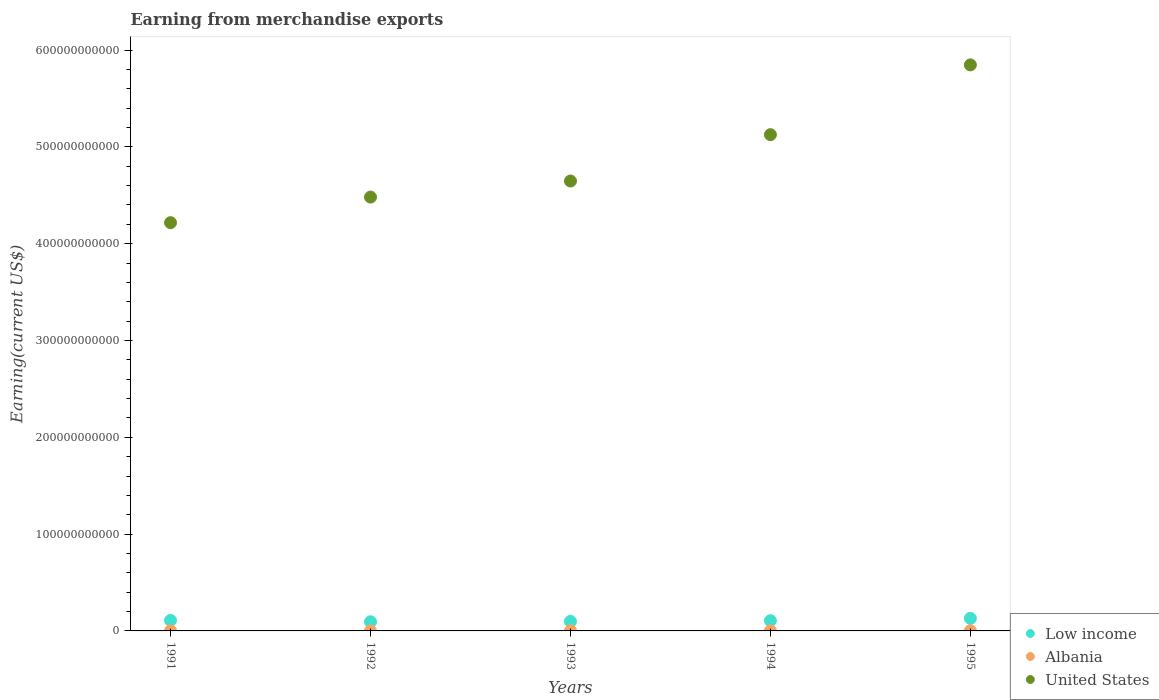How many different coloured dotlines are there?
Offer a terse response. 3. What is the amount earned from merchandise exports in United States in 1993?
Your answer should be compact. 4.65e+11. Across all years, what is the maximum amount earned from merchandise exports in Low income?
Your answer should be very brief. 1.30e+1. Across all years, what is the minimum amount earned from merchandise exports in United States?
Your answer should be very brief. 4.22e+11. What is the total amount earned from merchandise exports in Albania in the graph?
Provide a succinct answer. 6.37e+08. What is the difference between the amount earned from merchandise exports in United States in 1991 and that in 1995?
Give a very brief answer. -1.63e+11. What is the difference between the amount earned from merchandise exports in Low income in 1994 and the amount earned from merchandise exports in Albania in 1992?
Provide a succinct answer. 1.05e+1. What is the average amount earned from merchandise exports in United States per year?
Provide a short and direct response. 4.86e+11. In the year 1993, what is the difference between the amount earned from merchandise exports in United States and amount earned from merchandise exports in Albania?
Provide a short and direct response. 4.65e+11. What is the ratio of the amount earned from merchandise exports in Low income in 1993 to that in 1994?
Your answer should be very brief. 0.94. What is the difference between the highest and the second highest amount earned from merchandise exports in Albania?
Offer a terse response. 5.93e+07. What is the difference between the highest and the lowest amount earned from merchandise exports in Albania?
Keep it short and to the point. 1.32e+08. In how many years, is the amount earned from merchandise exports in Albania greater than the average amount earned from merchandise exports in Albania taken over all years?
Give a very brief answer. 2. Does the amount earned from merchandise exports in Low income monotonically increase over the years?
Provide a succinct answer. No. Is the amount earned from merchandise exports in United States strictly greater than the amount earned from merchandise exports in Low income over the years?
Give a very brief answer. Yes. How many dotlines are there?
Provide a short and direct response. 3. What is the difference between two consecutive major ticks on the Y-axis?
Make the answer very short. 1.00e+11. Are the values on the major ticks of Y-axis written in scientific E-notation?
Make the answer very short. No. Where does the legend appear in the graph?
Provide a succinct answer. Bottom right. How many legend labels are there?
Make the answer very short. 3. How are the legend labels stacked?
Give a very brief answer. Vertical. What is the title of the graph?
Provide a short and direct response. Earning from merchandise exports. Does "Bahrain" appear as one of the legend labels in the graph?
Your answer should be very brief. No. What is the label or title of the Y-axis?
Your answer should be very brief. Earning(current US$). What is the Earning(current US$) in Low income in 1991?
Ensure brevity in your answer.  1.08e+1. What is the Earning(current US$) in Albania in 1991?
Make the answer very short. 1.00e+08. What is the Earning(current US$) of United States in 1991?
Offer a terse response. 4.22e+11. What is the Earning(current US$) in Low income in 1992?
Offer a terse response. 9.42e+09. What is the Earning(current US$) in Albania in 1992?
Make the answer very short. 7.00e+07. What is the Earning(current US$) of United States in 1992?
Provide a succinct answer. 4.48e+11. What is the Earning(current US$) in Low income in 1993?
Keep it short and to the point. 9.91e+09. What is the Earning(current US$) of Albania in 1993?
Your answer should be very brief. 1.22e+08. What is the Earning(current US$) of United States in 1993?
Make the answer very short. 4.65e+11. What is the Earning(current US$) in Low income in 1994?
Offer a terse response. 1.06e+1. What is the Earning(current US$) of Albania in 1994?
Your answer should be very brief. 1.43e+08. What is the Earning(current US$) in United States in 1994?
Offer a very short reply. 5.13e+11. What is the Earning(current US$) of Low income in 1995?
Offer a very short reply. 1.30e+1. What is the Earning(current US$) in Albania in 1995?
Your answer should be compact. 2.02e+08. What is the Earning(current US$) of United States in 1995?
Ensure brevity in your answer.  5.85e+11. Across all years, what is the maximum Earning(current US$) in Low income?
Provide a short and direct response. 1.30e+1. Across all years, what is the maximum Earning(current US$) of Albania?
Your answer should be compact. 2.02e+08. Across all years, what is the maximum Earning(current US$) of United States?
Your response must be concise. 5.85e+11. Across all years, what is the minimum Earning(current US$) of Low income?
Your answer should be compact. 9.42e+09. Across all years, what is the minimum Earning(current US$) in Albania?
Provide a short and direct response. 7.00e+07. Across all years, what is the minimum Earning(current US$) of United States?
Your response must be concise. 4.22e+11. What is the total Earning(current US$) of Low income in the graph?
Ensure brevity in your answer.  5.38e+1. What is the total Earning(current US$) of Albania in the graph?
Give a very brief answer. 6.37e+08. What is the total Earning(current US$) of United States in the graph?
Offer a very short reply. 2.43e+12. What is the difference between the Earning(current US$) in Low income in 1991 and that in 1992?
Provide a short and direct response. 1.42e+09. What is the difference between the Earning(current US$) in Albania in 1991 and that in 1992?
Your answer should be compact. 3.00e+07. What is the difference between the Earning(current US$) of United States in 1991 and that in 1992?
Provide a succinct answer. -2.64e+1. What is the difference between the Earning(current US$) in Low income in 1991 and that in 1993?
Your answer should be compact. 9.40e+08. What is the difference between the Earning(current US$) of Albania in 1991 and that in 1993?
Provide a short and direct response. -2.25e+07. What is the difference between the Earning(current US$) in United States in 1991 and that in 1993?
Your response must be concise. -4.30e+1. What is the difference between the Earning(current US$) in Low income in 1991 and that in 1994?
Your answer should be very brief. 2.65e+08. What is the difference between the Earning(current US$) of Albania in 1991 and that in 1994?
Offer a very short reply. -4.27e+07. What is the difference between the Earning(current US$) in United States in 1991 and that in 1994?
Your answer should be compact. -9.09e+1. What is the difference between the Earning(current US$) in Low income in 1991 and that in 1995?
Keep it short and to the point. -2.14e+09. What is the difference between the Earning(current US$) in Albania in 1991 and that in 1995?
Your answer should be very brief. -1.02e+08. What is the difference between the Earning(current US$) in United States in 1991 and that in 1995?
Provide a short and direct response. -1.63e+11. What is the difference between the Earning(current US$) of Low income in 1992 and that in 1993?
Offer a terse response. -4.84e+08. What is the difference between the Earning(current US$) of Albania in 1992 and that in 1993?
Offer a very short reply. -5.25e+07. What is the difference between the Earning(current US$) of United States in 1992 and that in 1993?
Offer a very short reply. -1.66e+1. What is the difference between the Earning(current US$) in Low income in 1992 and that in 1994?
Your answer should be compact. -1.16e+09. What is the difference between the Earning(current US$) in Albania in 1992 and that in 1994?
Your answer should be very brief. -7.27e+07. What is the difference between the Earning(current US$) in United States in 1992 and that in 1994?
Keep it short and to the point. -6.45e+1. What is the difference between the Earning(current US$) of Low income in 1992 and that in 1995?
Provide a short and direct response. -3.57e+09. What is the difference between the Earning(current US$) in Albania in 1992 and that in 1995?
Your response must be concise. -1.32e+08. What is the difference between the Earning(current US$) of United States in 1992 and that in 1995?
Give a very brief answer. -1.37e+11. What is the difference between the Earning(current US$) of Low income in 1993 and that in 1994?
Keep it short and to the point. -6.75e+08. What is the difference between the Earning(current US$) of Albania in 1993 and that in 1994?
Your answer should be compact. -2.02e+07. What is the difference between the Earning(current US$) in United States in 1993 and that in 1994?
Offer a terse response. -4.79e+1. What is the difference between the Earning(current US$) in Low income in 1993 and that in 1995?
Give a very brief answer. -3.08e+09. What is the difference between the Earning(current US$) in Albania in 1993 and that in 1995?
Offer a very short reply. -7.95e+07. What is the difference between the Earning(current US$) of United States in 1993 and that in 1995?
Provide a succinct answer. -1.20e+11. What is the difference between the Earning(current US$) of Low income in 1994 and that in 1995?
Your answer should be very brief. -2.41e+09. What is the difference between the Earning(current US$) in Albania in 1994 and that in 1995?
Offer a very short reply. -5.93e+07. What is the difference between the Earning(current US$) of United States in 1994 and that in 1995?
Make the answer very short. -7.21e+1. What is the difference between the Earning(current US$) of Low income in 1991 and the Earning(current US$) of Albania in 1992?
Keep it short and to the point. 1.08e+1. What is the difference between the Earning(current US$) in Low income in 1991 and the Earning(current US$) in United States in 1992?
Your answer should be compact. -4.37e+11. What is the difference between the Earning(current US$) of Albania in 1991 and the Earning(current US$) of United States in 1992?
Ensure brevity in your answer.  -4.48e+11. What is the difference between the Earning(current US$) in Low income in 1991 and the Earning(current US$) in Albania in 1993?
Keep it short and to the point. 1.07e+1. What is the difference between the Earning(current US$) of Low income in 1991 and the Earning(current US$) of United States in 1993?
Your answer should be very brief. -4.54e+11. What is the difference between the Earning(current US$) in Albania in 1991 and the Earning(current US$) in United States in 1993?
Provide a short and direct response. -4.65e+11. What is the difference between the Earning(current US$) of Low income in 1991 and the Earning(current US$) of Albania in 1994?
Your answer should be very brief. 1.07e+1. What is the difference between the Earning(current US$) of Low income in 1991 and the Earning(current US$) of United States in 1994?
Your answer should be very brief. -5.02e+11. What is the difference between the Earning(current US$) of Albania in 1991 and the Earning(current US$) of United States in 1994?
Your answer should be compact. -5.13e+11. What is the difference between the Earning(current US$) of Low income in 1991 and the Earning(current US$) of Albania in 1995?
Your response must be concise. 1.06e+1. What is the difference between the Earning(current US$) of Low income in 1991 and the Earning(current US$) of United States in 1995?
Make the answer very short. -5.74e+11. What is the difference between the Earning(current US$) in Albania in 1991 and the Earning(current US$) in United States in 1995?
Keep it short and to the point. -5.85e+11. What is the difference between the Earning(current US$) in Low income in 1992 and the Earning(current US$) in Albania in 1993?
Your answer should be compact. 9.30e+09. What is the difference between the Earning(current US$) of Low income in 1992 and the Earning(current US$) of United States in 1993?
Provide a short and direct response. -4.55e+11. What is the difference between the Earning(current US$) of Albania in 1992 and the Earning(current US$) of United States in 1993?
Your answer should be compact. -4.65e+11. What is the difference between the Earning(current US$) in Low income in 1992 and the Earning(current US$) in Albania in 1994?
Your answer should be compact. 9.28e+09. What is the difference between the Earning(current US$) of Low income in 1992 and the Earning(current US$) of United States in 1994?
Give a very brief answer. -5.03e+11. What is the difference between the Earning(current US$) of Albania in 1992 and the Earning(current US$) of United States in 1994?
Provide a succinct answer. -5.13e+11. What is the difference between the Earning(current US$) of Low income in 1992 and the Earning(current US$) of Albania in 1995?
Provide a succinct answer. 9.22e+09. What is the difference between the Earning(current US$) in Low income in 1992 and the Earning(current US$) in United States in 1995?
Ensure brevity in your answer.  -5.75e+11. What is the difference between the Earning(current US$) of Albania in 1992 and the Earning(current US$) of United States in 1995?
Your answer should be compact. -5.85e+11. What is the difference between the Earning(current US$) of Low income in 1993 and the Earning(current US$) of Albania in 1994?
Keep it short and to the point. 9.76e+09. What is the difference between the Earning(current US$) of Low income in 1993 and the Earning(current US$) of United States in 1994?
Offer a very short reply. -5.03e+11. What is the difference between the Earning(current US$) of Albania in 1993 and the Earning(current US$) of United States in 1994?
Offer a terse response. -5.13e+11. What is the difference between the Earning(current US$) in Low income in 1993 and the Earning(current US$) in Albania in 1995?
Your answer should be very brief. 9.71e+09. What is the difference between the Earning(current US$) of Low income in 1993 and the Earning(current US$) of United States in 1995?
Offer a very short reply. -5.75e+11. What is the difference between the Earning(current US$) in Albania in 1993 and the Earning(current US$) in United States in 1995?
Your response must be concise. -5.85e+11. What is the difference between the Earning(current US$) in Low income in 1994 and the Earning(current US$) in Albania in 1995?
Make the answer very short. 1.04e+1. What is the difference between the Earning(current US$) of Low income in 1994 and the Earning(current US$) of United States in 1995?
Provide a short and direct response. -5.74e+11. What is the difference between the Earning(current US$) of Albania in 1994 and the Earning(current US$) of United States in 1995?
Give a very brief answer. -5.85e+11. What is the average Earning(current US$) of Low income per year?
Provide a succinct answer. 1.08e+1. What is the average Earning(current US$) in Albania per year?
Provide a succinct answer. 1.27e+08. What is the average Earning(current US$) of United States per year?
Offer a very short reply. 4.86e+11. In the year 1991, what is the difference between the Earning(current US$) in Low income and Earning(current US$) in Albania?
Provide a succinct answer. 1.07e+1. In the year 1991, what is the difference between the Earning(current US$) in Low income and Earning(current US$) in United States?
Provide a short and direct response. -4.11e+11. In the year 1991, what is the difference between the Earning(current US$) in Albania and Earning(current US$) in United States?
Provide a short and direct response. -4.22e+11. In the year 1992, what is the difference between the Earning(current US$) in Low income and Earning(current US$) in Albania?
Ensure brevity in your answer.  9.35e+09. In the year 1992, what is the difference between the Earning(current US$) in Low income and Earning(current US$) in United States?
Make the answer very short. -4.39e+11. In the year 1992, what is the difference between the Earning(current US$) of Albania and Earning(current US$) of United States?
Your answer should be compact. -4.48e+11. In the year 1993, what is the difference between the Earning(current US$) of Low income and Earning(current US$) of Albania?
Ensure brevity in your answer.  9.78e+09. In the year 1993, what is the difference between the Earning(current US$) of Low income and Earning(current US$) of United States?
Give a very brief answer. -4.55e+11. In the year 1993, what is the difference between the Earning(current US$) of Albania and Earning(current US$) of United States?
Offer a very short reply. -4.65e+11. In the year 1994, what is the difference between the Earning(current US$) of Low income and Earning(current US$) of Albania?
Your answer should be compact. 1.04e+1. In the year 1994, what is the difference between the Earning(current US$) in Low income and Earning(current US$) in United States?
Offer a terse response. -5.02e+11. In the year 1994, what is the difference between the Earning(current US$) in Albania and Earning(current US$) in United States?
Your answer should be very brief. -5.12e+11. In the year 1995, what is the difference between the Earning(current US$) in Low income and Earning(current US$) in Albania?
Your response must be concise. 1.28e+1. In the year 1995, what is the difference between the Earning(current US$) of Low income and Earning(current US$) of United States?
Ensure brevity in your answer.  -5.72e+11. In the year 1995, what is the difference between the Earning(current US$) of Albania and Earning(current US$) of United States?
Your answer should be very brief. -5.85e+11. What is the ratio of the Earning(current US$) in Low income in 1991 to that in 1992?
Your response must be concise. 1.15. What is the ratio of the Earning(current US$) in Albania in 1991 to that in 1992?
Offer a very short reply. 1.43. What is the ratio of the Earning(current US$) in United States in 1991 to that in 1992?
Your response must be concise. 0.94. What is the ratio of the Earning(current US$) in Low income in 1991 to that in 1993?
Keep it short and to the point. 1.09. What is the ratio of the Earning(current US$) of Albania in 1991 to that in 1993?
Provide a succinct answer. 0.82. What is the ratio of the Earning(current US$) in United States in 1991 to that in 1993?
Provide a short and direct response. 0.91. What is the ratio of the Earning(current US$) in Low income in 1991 to that in 1994?
Offer a terse response. 1.03. What is the ratio of the Earning(current US$) in Albania in 1991 to that in 1994?
Provide a short and direct response. 0.7. What is the ratio of the Earning(current US$) in United States in 1991 to that in 1994?
Your answer should be very brief. 0.82. What is the ratio of the Earning(current US$) of Low income in 1991 to that in 1995?
Ensure brevity in your answer.  0.83. What is the ratio of the Earning(current US$) of Albania in 1991 to that in 1995?
Provide a succinct answer. 0.49. What is the ratio of the Earning(current US$) in United States in 1991 to that in 1995?
Keep it short and to the point. 0.72. What is the ratio of the Earning(current US$) of Low income in 1992 to that in 1993?
Your response must be concise. 0.95. What is the ratio of the Earning(current US$) in Albania in 1992 to that in 1993?
Your response must be concise. 0.57. What is the ratio of the Earning(current US$) of Low income in 1992 to that in 1994?
Your response must be concise. 0.89. What is the ratio of the Earning(current US$) in Albania in 1992 to that in 1994?
Keep it short and to the point. 0.49. What is the ratio of the Earning(current US$) in United States in 1992 to that in 1994?
Offer a very short reply. 0.87. What is the ratio of the Earning(current US$) of Low income in 1992 to that in 1995?
Offer a terse response. 0.73. What is the ratio of the Earning(current US$) of Albania in 1992 to that in 1995?
Provide a succinct answer. 0.35. What is the ratio of the Earning(current US$) in United States in 1992 to that in 1995?
Make the answer very short. 0.77. What is the ratio of the Earning(current US$) of Low income in 1993 to that in 1994?
Offer a terse response. 0.94. What is the ratio of the Earning(current US$) of Albania in 1993 to that in 1994?
Provide a succinct answer. 0.86. What is the ratio of the Earning(current US$) in United States in 1993 to that in 1994?
Provide a short and direct response. 0.91. What is the ratio of the Earning(current US$) of Low income in 1993 to that in 1995?
Your response must be concise. 0.76. What is the ratio of the Earning(current US$) of Albania in 1993 to that in 1995?
Your response must be concise. 0.61. What is the ratio of the Earning(current US$) of United States in 1993 to that in 1995?
Your answer should be compact. 0.79. What is the ratio of the Earning(current US$) in Low income in 1994 to that in 1995?
Your response must be concise. 0.81. What is the ratio of the Earning(current US$) in Albania in 1994 to that in 1995?
Provide a succinct answer. 0.71. What is the ratio of the Earning(current US$) in United States in 1994 to that in 1995?
Make the answer very short. 0.88. What is the difference between the highest and the second highest Earning(current US$) in Low income?
Your answer should be compact. 2.14e+09. What is the difference between the highest and the second highest Earning(current US$) of Albania?
Ensure brevity in your answer.  5.93e+07. What is the difference between the highest and the second highest Earning(current US$) in United States?
Keep it short and to the point. 7.21e+1. What is the difference between the highest and the lowest Earning(current US$) of Low income?
Your answer should be compact. 3.57e+09. What is the difference between the highest and the lowest Earning(current US$) in Albania?
Make the answer very short. 1.32e+08. What is the difference between the highest and the lowest Earning(current US$) in United States?
Provide a short and direct response. 1.63e+11. 